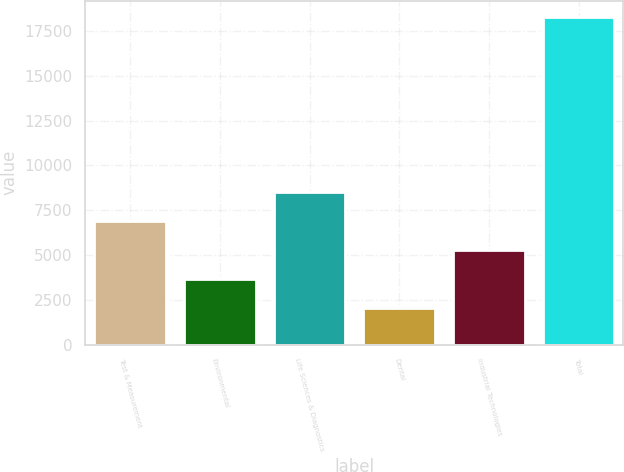<chart> <loc_0><loc_0><loc_500><loc_500><bar_chart><fcel>Test & Measurement<fcel>Environmental<fcel>Life Sciences & Diagnostics<fcel>Dental<fcel>Industrial Technologies<fcel>Total<nl><fcel>6894.15<fcel>3646.65<fcel>8517.9<fcel>2022.9<fcel>5270.4<fcel>18260.4<nl></chart> 